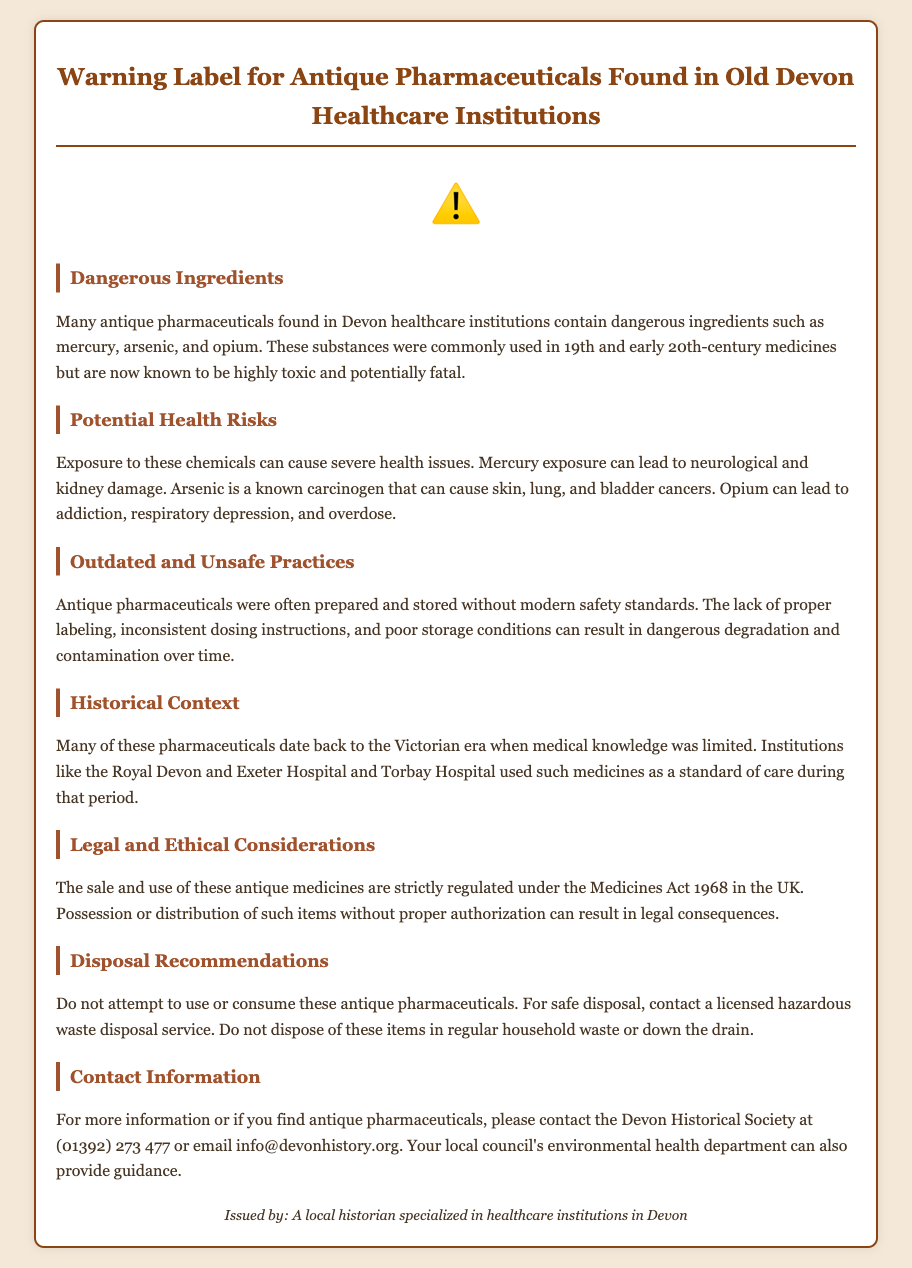What dangerous ingredients are mentioned? The document lists specific dangerous ingredients found in antique pharmaceuticals, including mercury, arsenic, and opium.
Answer: mercury, arsenic, opium What historical era is referenced? The document states that many antique pharmaceuticals date back to the Victorian era when medical knowledge was limited.
Answer: Victorian era What is a potential health risk of mercury exposure? The document provides information on the health risks associated with exposure to mercury, specifically mentioning neurological and kidney damage.
Answer: neurological and kidney damage Which healthcare institutions are mentioned? The document names institutions that used these antique medicines, specifically the Royal Devon and Exeter Hospital and Torbay Hospital.
Answer: Royal Devon and Exeter Hospital, Torbay Hospital What year is the Medicines Act referenced? The document states that the sale and use of these antique medicines are regulated under the Medicines Act, mentioning the year 1968.
Answer: 1968 What should you do with antique pharmaceuticals? The document offers disposal recommendations, stating not to attempt to use or consume antique pharmaceuticals and to contact licensed hazardous waste disposal services.
Answer: contact a licensed hazardous waste disposal service What does the warning symbol signify? The document features a warning symbol, which generally signifies danger, but further context can be drawn from the discussed risks associated with the contents.
Answer: danger What kind of historical society should be contacted for more information? The document provides contact information for the Devon Historical Society for inquiries related to finding antique pharmaceuticals.
Answer: Devon Historical Society 